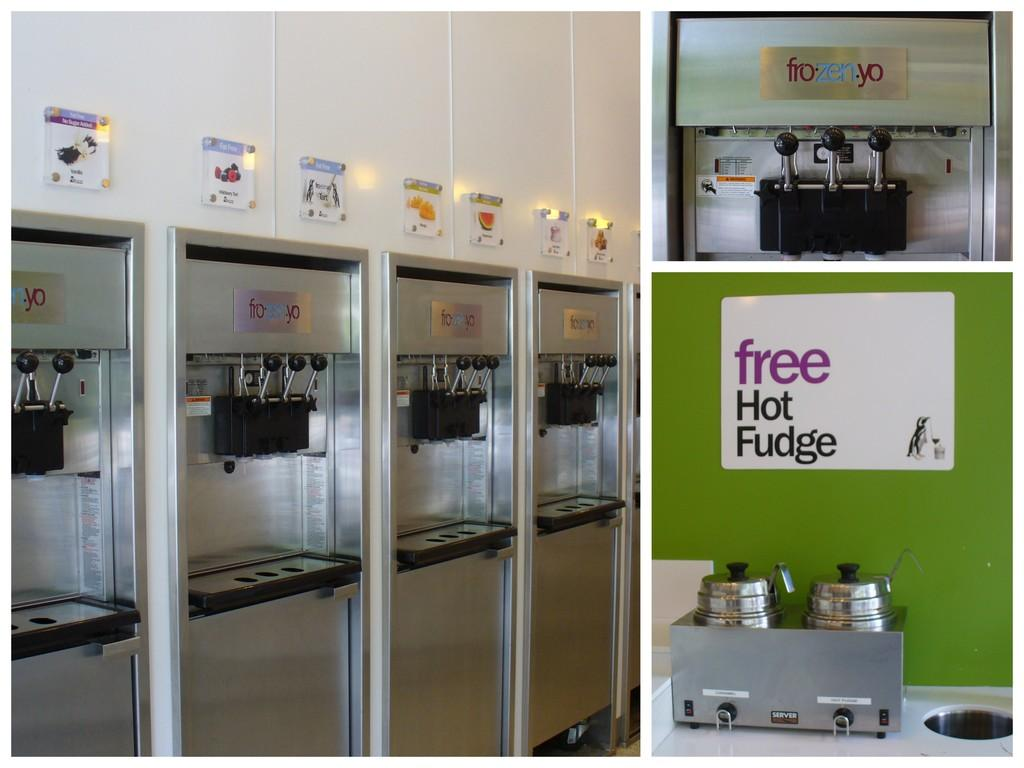<image>
Render a clear and concise summary of the photo. a sign that has the word free and hot on it in an ice cream parlor 